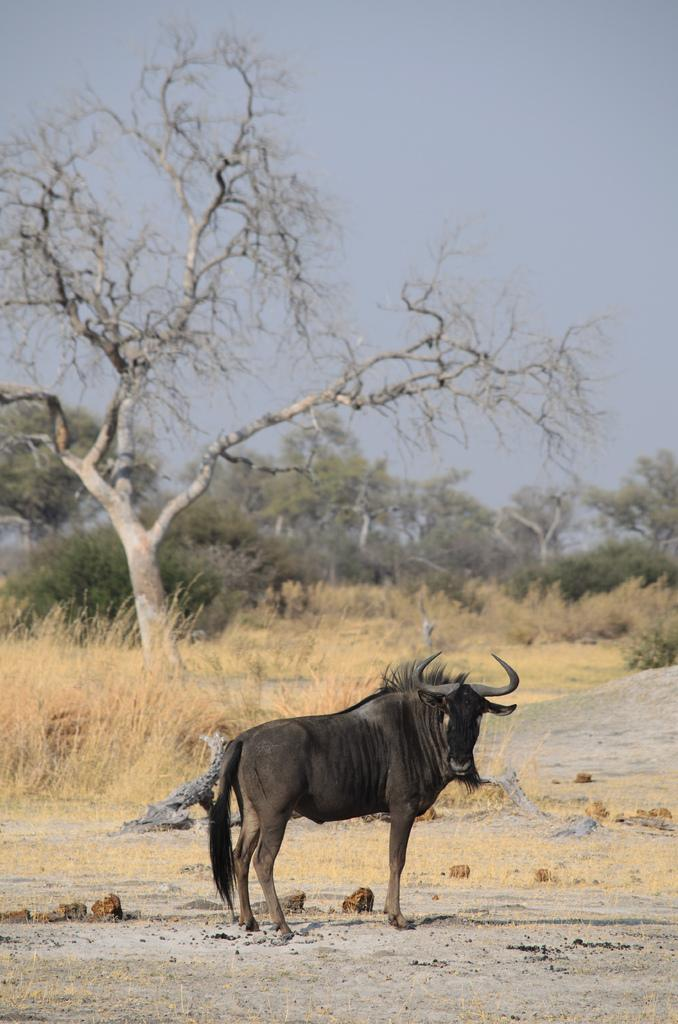What type of animal is in the image? The type of animal cannot be determined from the provided facts. What can be seen in the background of the image? There is grass, trees, and the sky visible in the background of the image. What type of yam is being used as a prop in the image? There is no yam present in the image. How does the wind affect the animal in the image? The provided facts do not mention any wind or its effect on the animal in the image. 